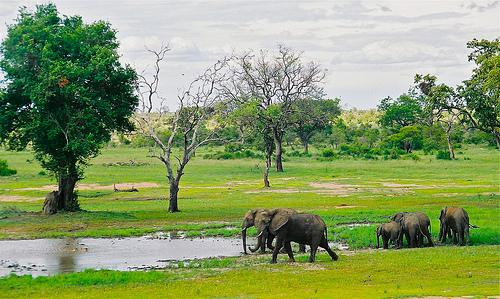Question: what was the weather like in this photo?
Choices:
A. Sunny.
B. Rainy.
C. Hazy.
D. Gloomy.
Answer with the letter. Answer: A Question: how was this photo taken?
Choices:
A. Underwater.
B. With a camera.
C. From a plane.
D. On a tripod.
Answer with the letter. Answer: B Question: who captured this photo?
Choices:
A. A photographer.
B. A farmer.
C. A journalist.
D. A detective.
Answer with the letter. Answer: A Question: what are the animals represented?
Choices:
A. Elephants.
B. Horses.
C. Cows.
D. Zebras.
Answer with the letter. Answer: A Question: what are the elephants in the background doing?
Choices:
A. Sleeping.
B. Running.
C. Feedings.
D. Splashing.
Answer with the letter. Answer: C Question: where was this picture taken?
Choices:
A. In an open field.
B. Desert.
C. Pasture.
D. Ranch.
Answer with the letter. Answer: A 